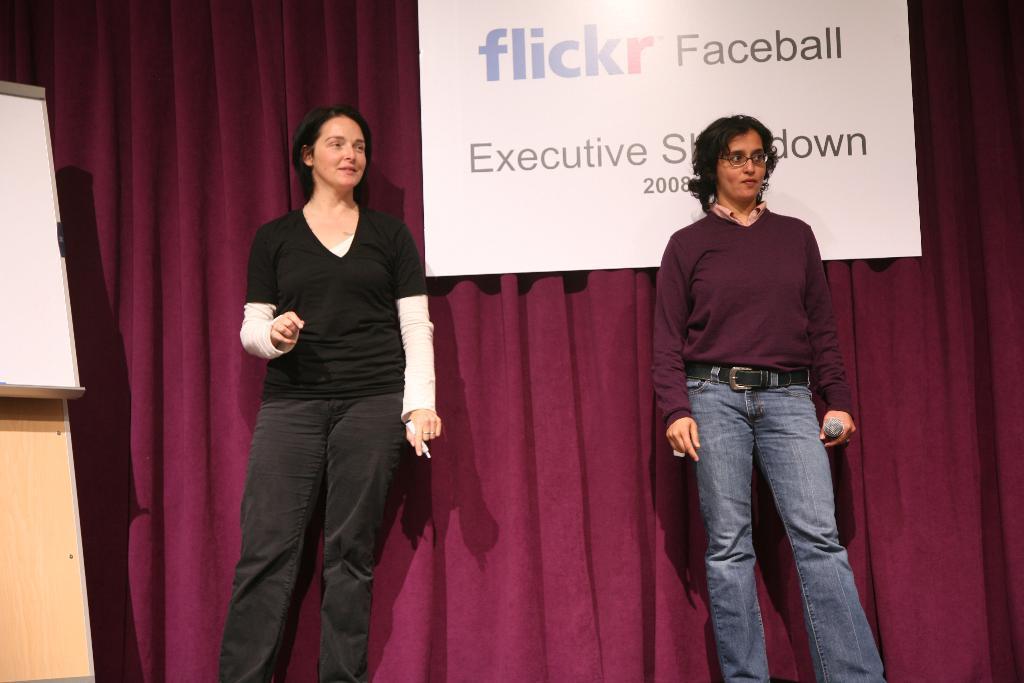Can you describe this image briefly? In this image we can see this person wearing black T-shirt is holding a marker and this person wearing maroon color T-shirt is holding a mic and they both are standing here. Here we can see the board and in the background, we can see the maroon color curtains and the board on which we can see some text. 